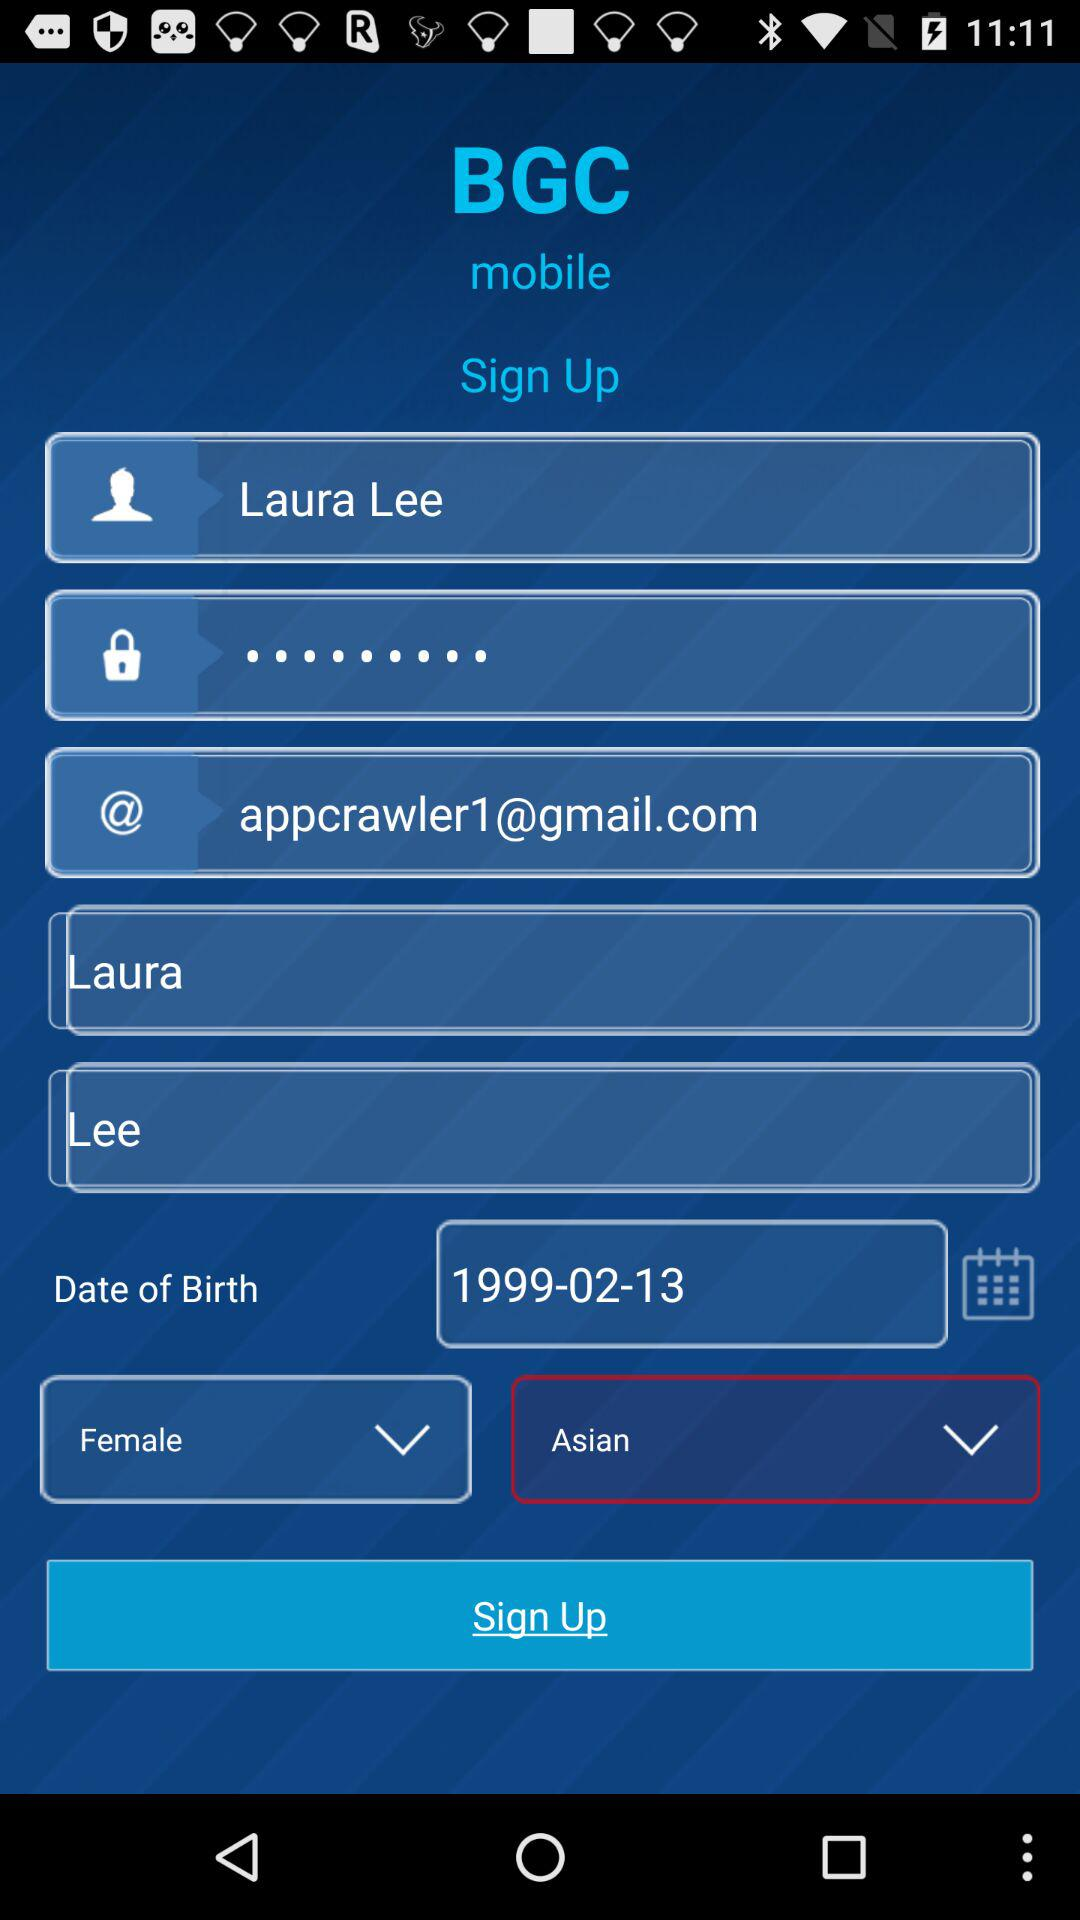What is the email address? The email address is appcrawler1@gmail.com. 